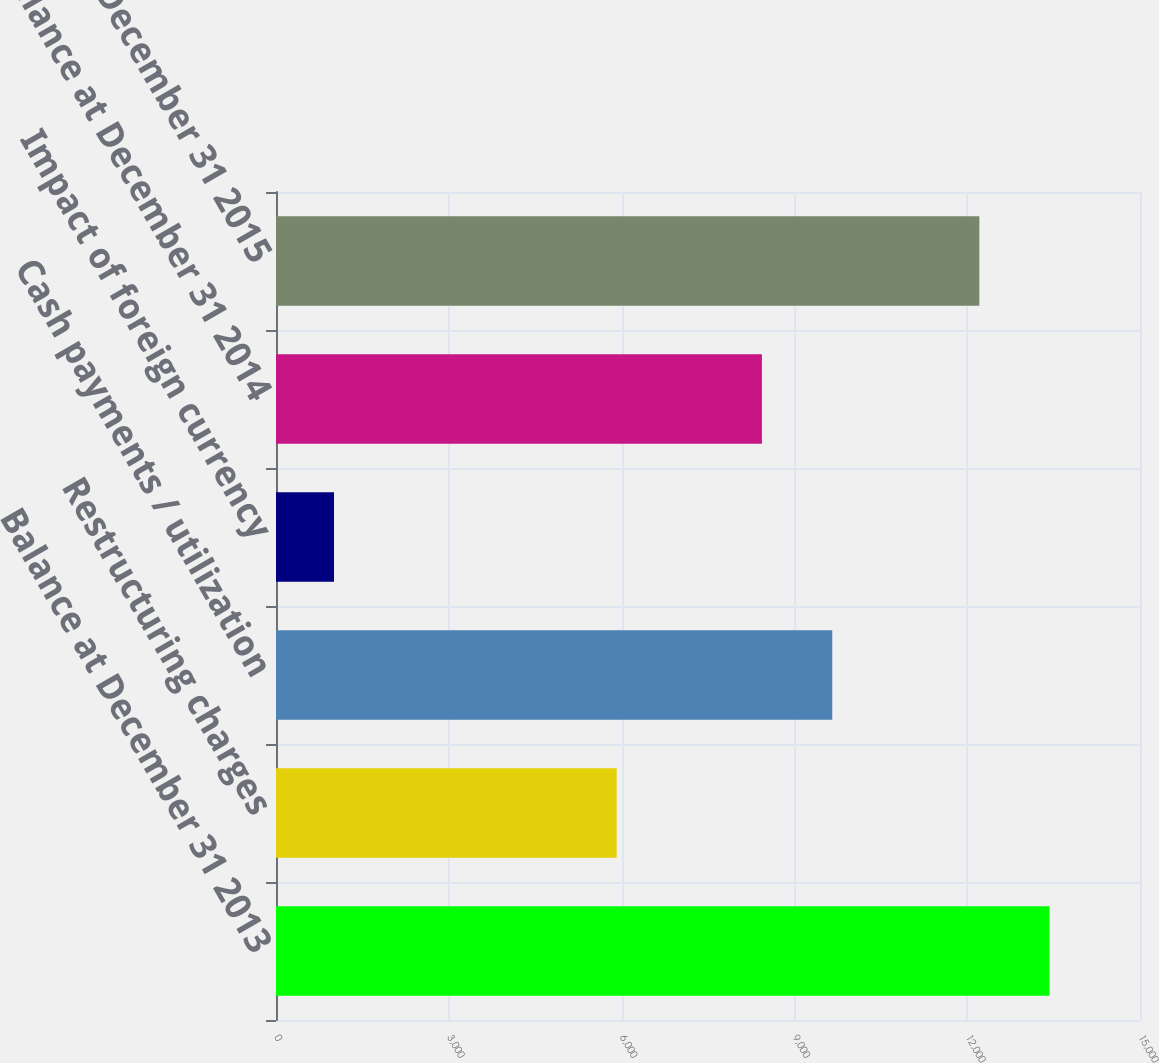Convert chart. <chart><loc_0><loc_0><loc_500><loc_500><bar_chart><fcel>Balance at December 31 2013<fcel>Restructuring charges<fcel>Cash payments / utilization<fcel>Impact of foreign currency<fcel>Balance at December 31 2014<fcel>Balance at December 31 2015<nl><fcel>13428.8<fcel>5915<fcel>9657<fcel>1007<fcel>8436<fcel>12211<nl></chart> 